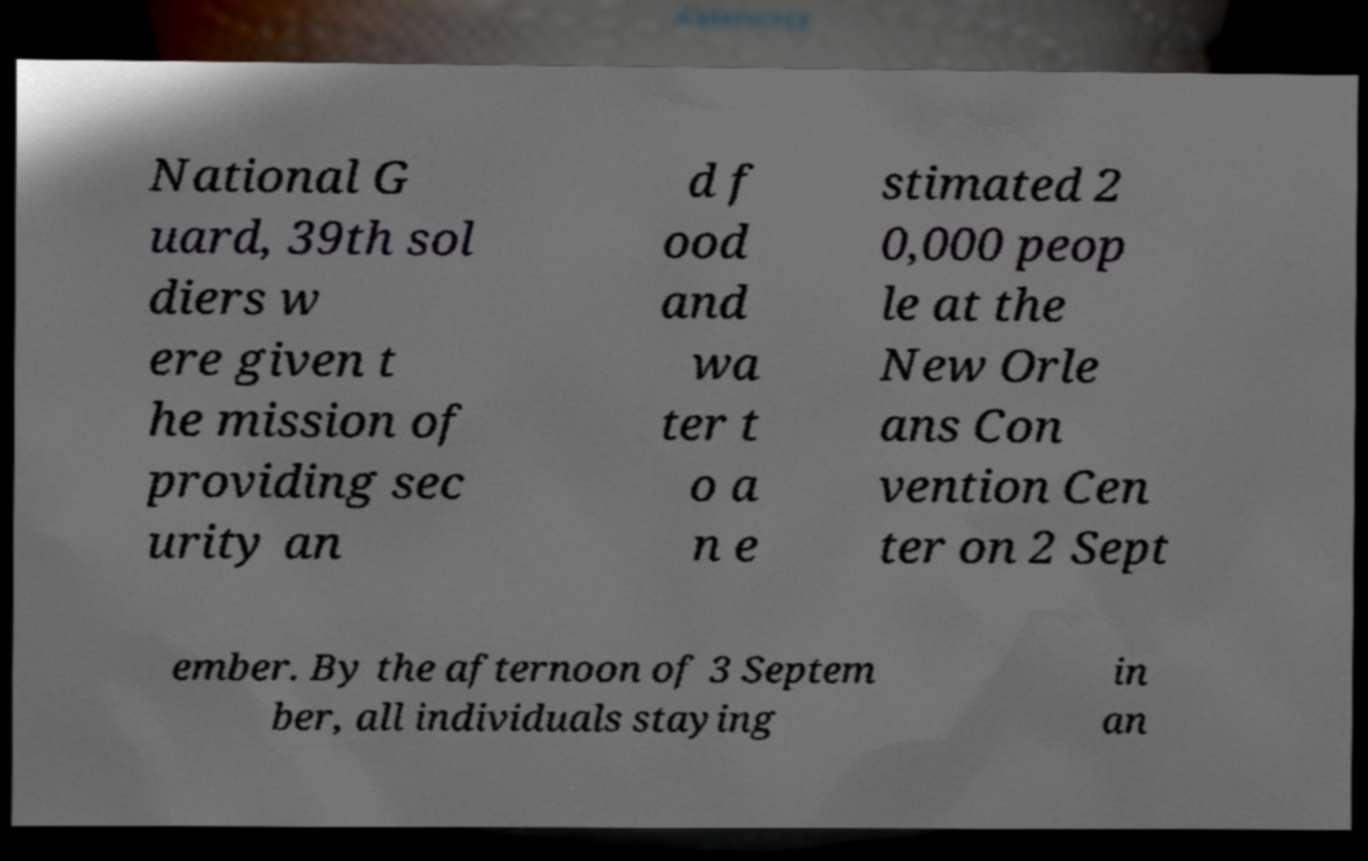Can you accurately transcribe the text from the provided image for me? National G uard, 39th sol diers w ere given t he mission of providing sec urity an d f ood and wa ter t o a n e stimated 2 0,000 peop le at the New Orle ans Con vention Cen ter on 2 Sept ember. By the afternoon of 3 Septem ber, all individuals staying in an 